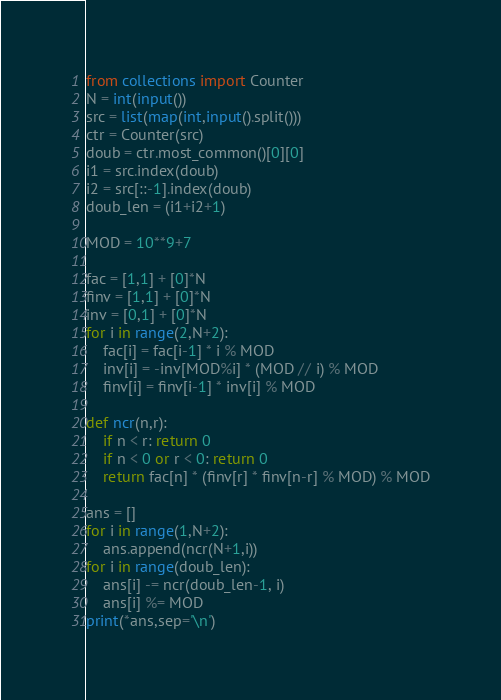Convert code to text. <code><loc_0><loc_0><loc_500><loc_500><_Python_>from collections import Counter
N = int(input())
src = list(map(int,input().split()))
ctr = Counter(src)
doub = ctr.most_common()[0][0]
i1 = src.index(doub)
i2 = src[::-1].index(doub)
doub_len = (i1+i2+1)

MOD = 10**9+7

fac = [1,1] + [0]*N
finv = [1,1] + [0]*N
inv = [0,1] + [0]*N
for i in range(2,N+2):
    fac[i] = fac[i-1] * i % MOD
    inv[i] = -inv[MOD%i] * (MOD // i) % MOD
    finv[i] = finv[i-1] * inv[i] % MOD

def ncr(n,r):
    if n < r: return 0
    if n < 0 or r < 0: return 0
    return fac[n] * (finv[r] * finv[n-r] % MOD) % MOD

ans = []
for i in range(1,N+2):
    ans.append(ncr(N+1,i))
for i in range(doub_len):
    ans[i] -= ncr(doub_len-1, i)
    ans[i] %= MOD
print(*ans,sep='\n')</code> 